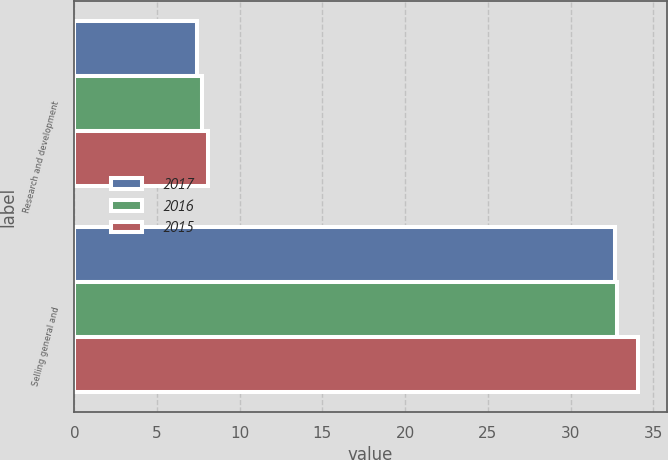<chart> <loc_0><loc_0><loc_500><loc_500><stacked_bar_chart><ecel><fcel>Research and development<fcel>Selling general and<nl><fcel>2017<fcel>7.4<fcel>32.7<nl><fcel>2016<fcel>7.7<fcel>32.8<nl><fcel>2015<fcel>8.1<fcel>34.1<nl></chart> 